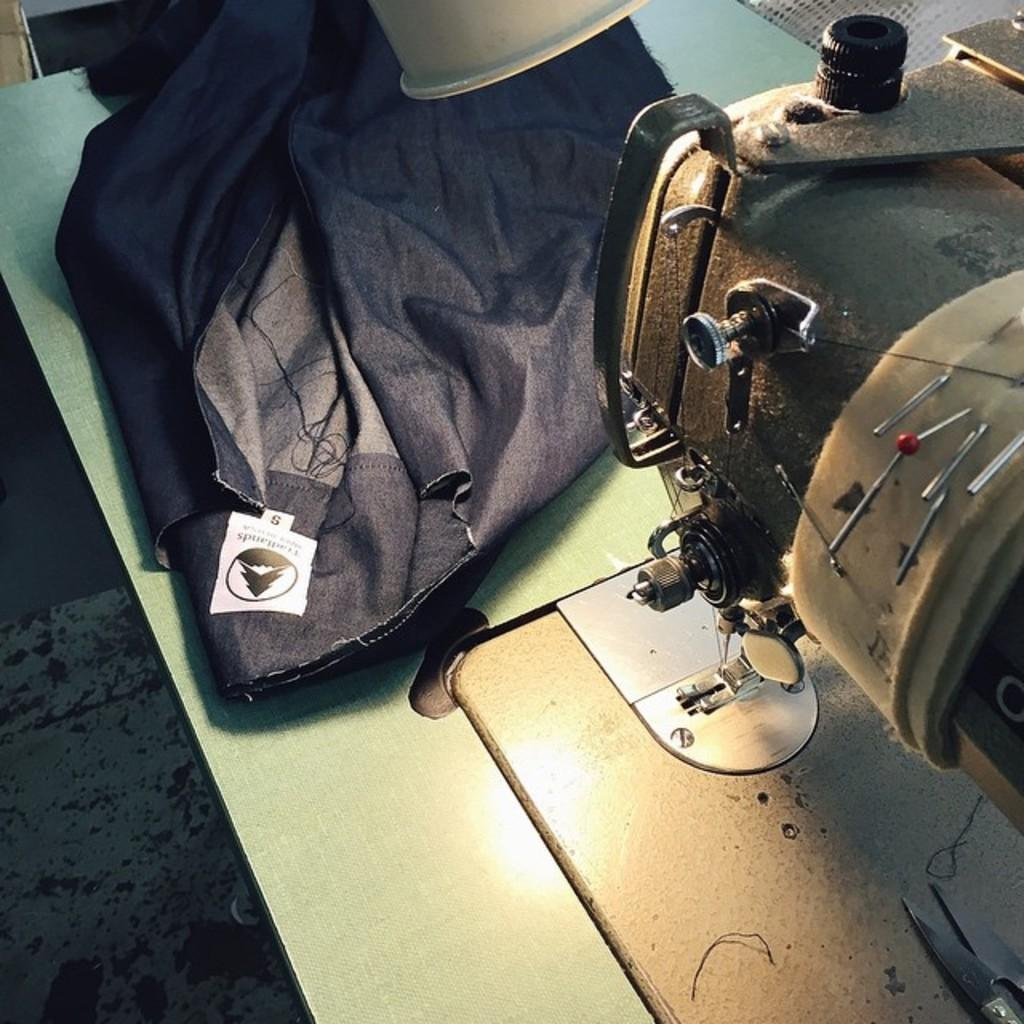What is the main object in the image? There is a sewing machine in the image. What is placed on the sewing machine? There is a cloth on the sewing machine. Is there anything on the cloth? Yes, there is an object on the cloth. What type of animals can be seen at the zoo in the image? There is no zoo or animals present in the image; it features a sewing machine with a cloth and an object on it. 